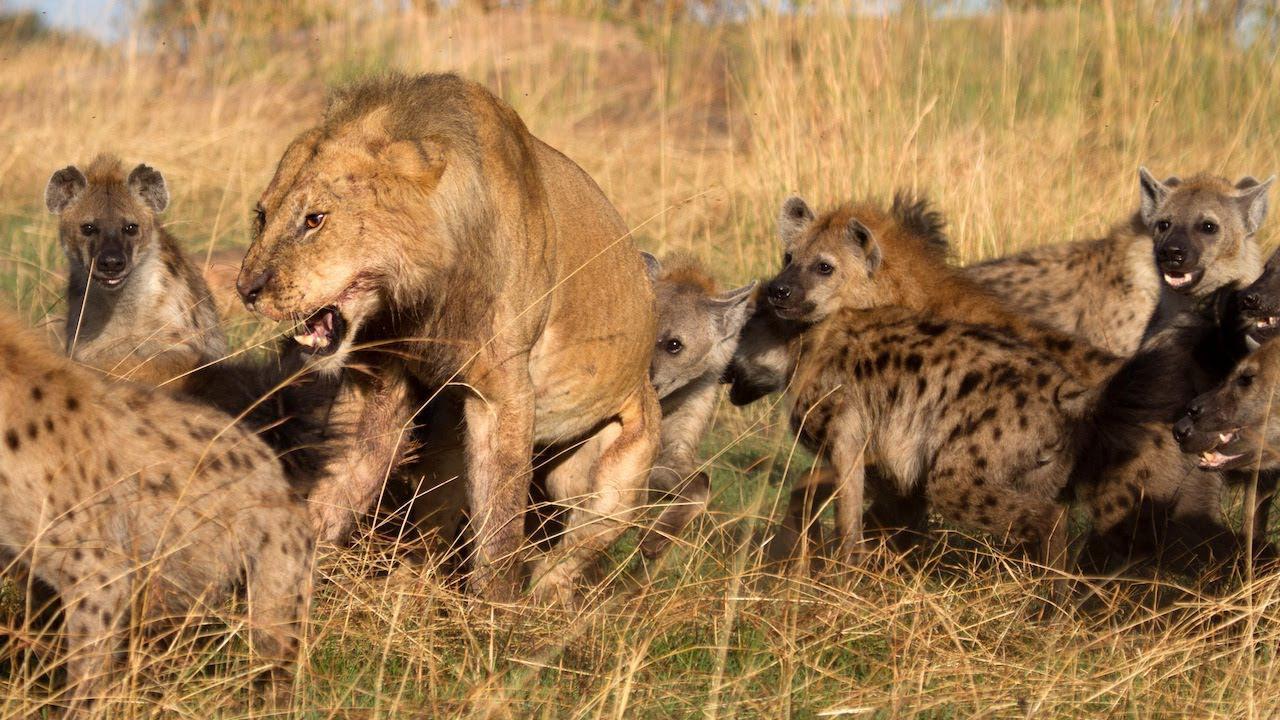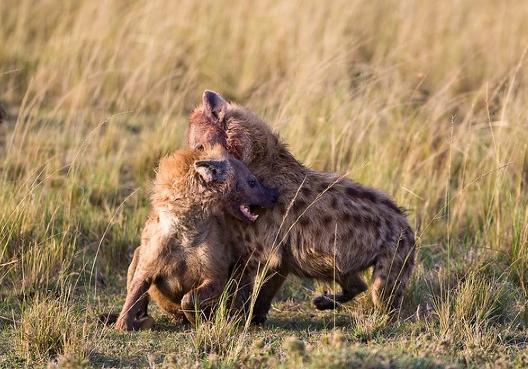The first image is the image on the left, the second image is the image on the right. For the images shown, is this caption "At least one image includes two hyenas fighting each other, with some bared fangs showing." true? Answer yes or no. Yes. The first image is the image on the left, the second image is the image on the right. For the images shown, is this caption "There are atleast 4 Hyenas total" true? Answer yes or no. Yes. 